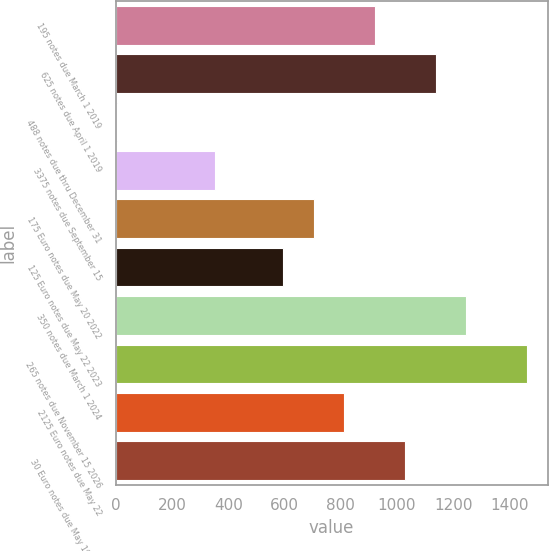<chart> <loc_0><loc_0><loc_500><loc_500><bar_chart><fcel>195 notes due March 1 2019<fcel>625 notes due April 1 2019<fcel>488 notes due thru December 31<fcel>3375 notes due September 15<fcel>175 Euro notes due May 20 2022<fcel>125 Euro notes due May 22 2023<fcel>350 notes due March 1 2024<fcel>265 notes due November 15 2026<fcel>2125 Euro notes due May 22<fcel>30 Euro notes due May 19 2034<nl><fcel>920.9<fcel>1137.5<fcel>4<fcel>354<fcel>704.3<fcel>596<fcel>1245.8<fcel>1462.4<fcel>812.6<fcel>1029.2<nl></chart> 